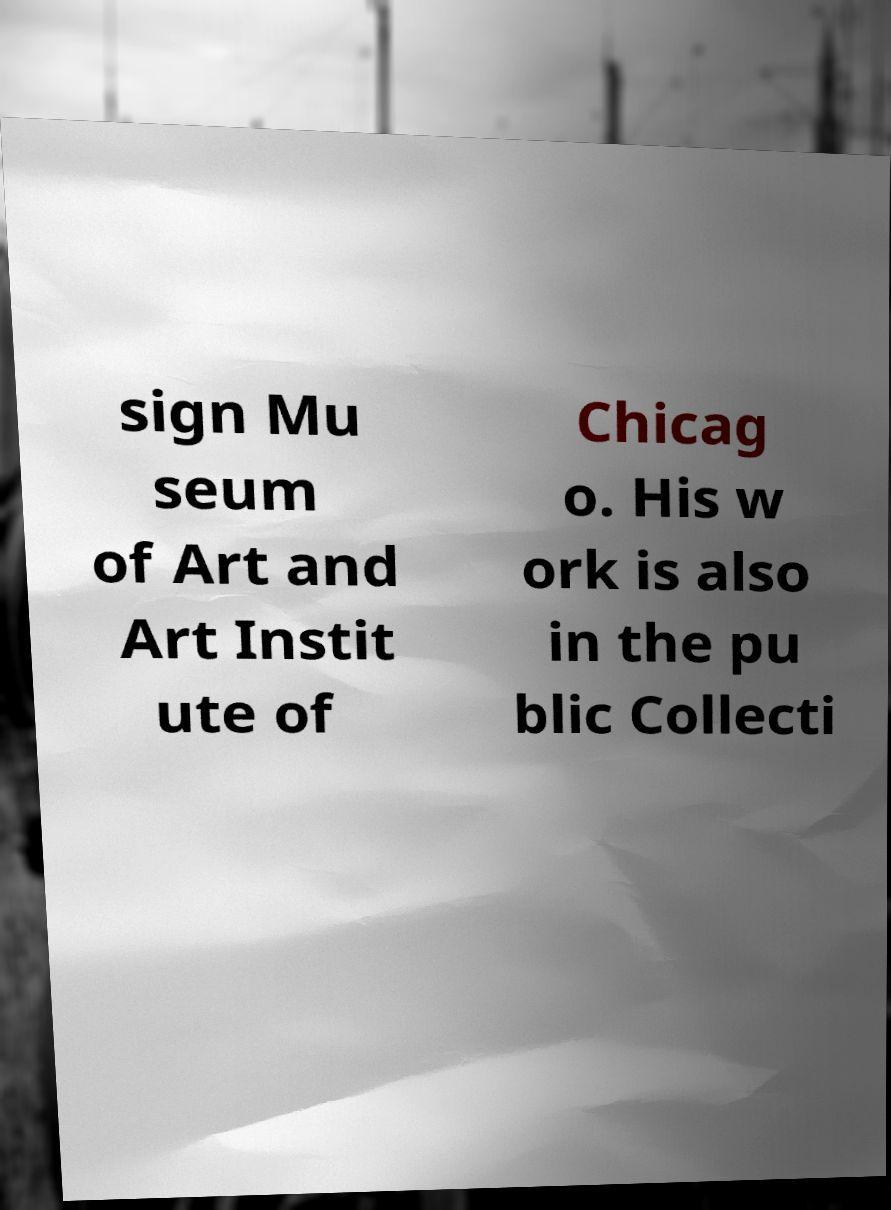Please read and relay the text visible in this image. What does it say? sign Mu seum of Art and Art Instit ute of Chicag o. His w ork is also in the pu blic Collecti 